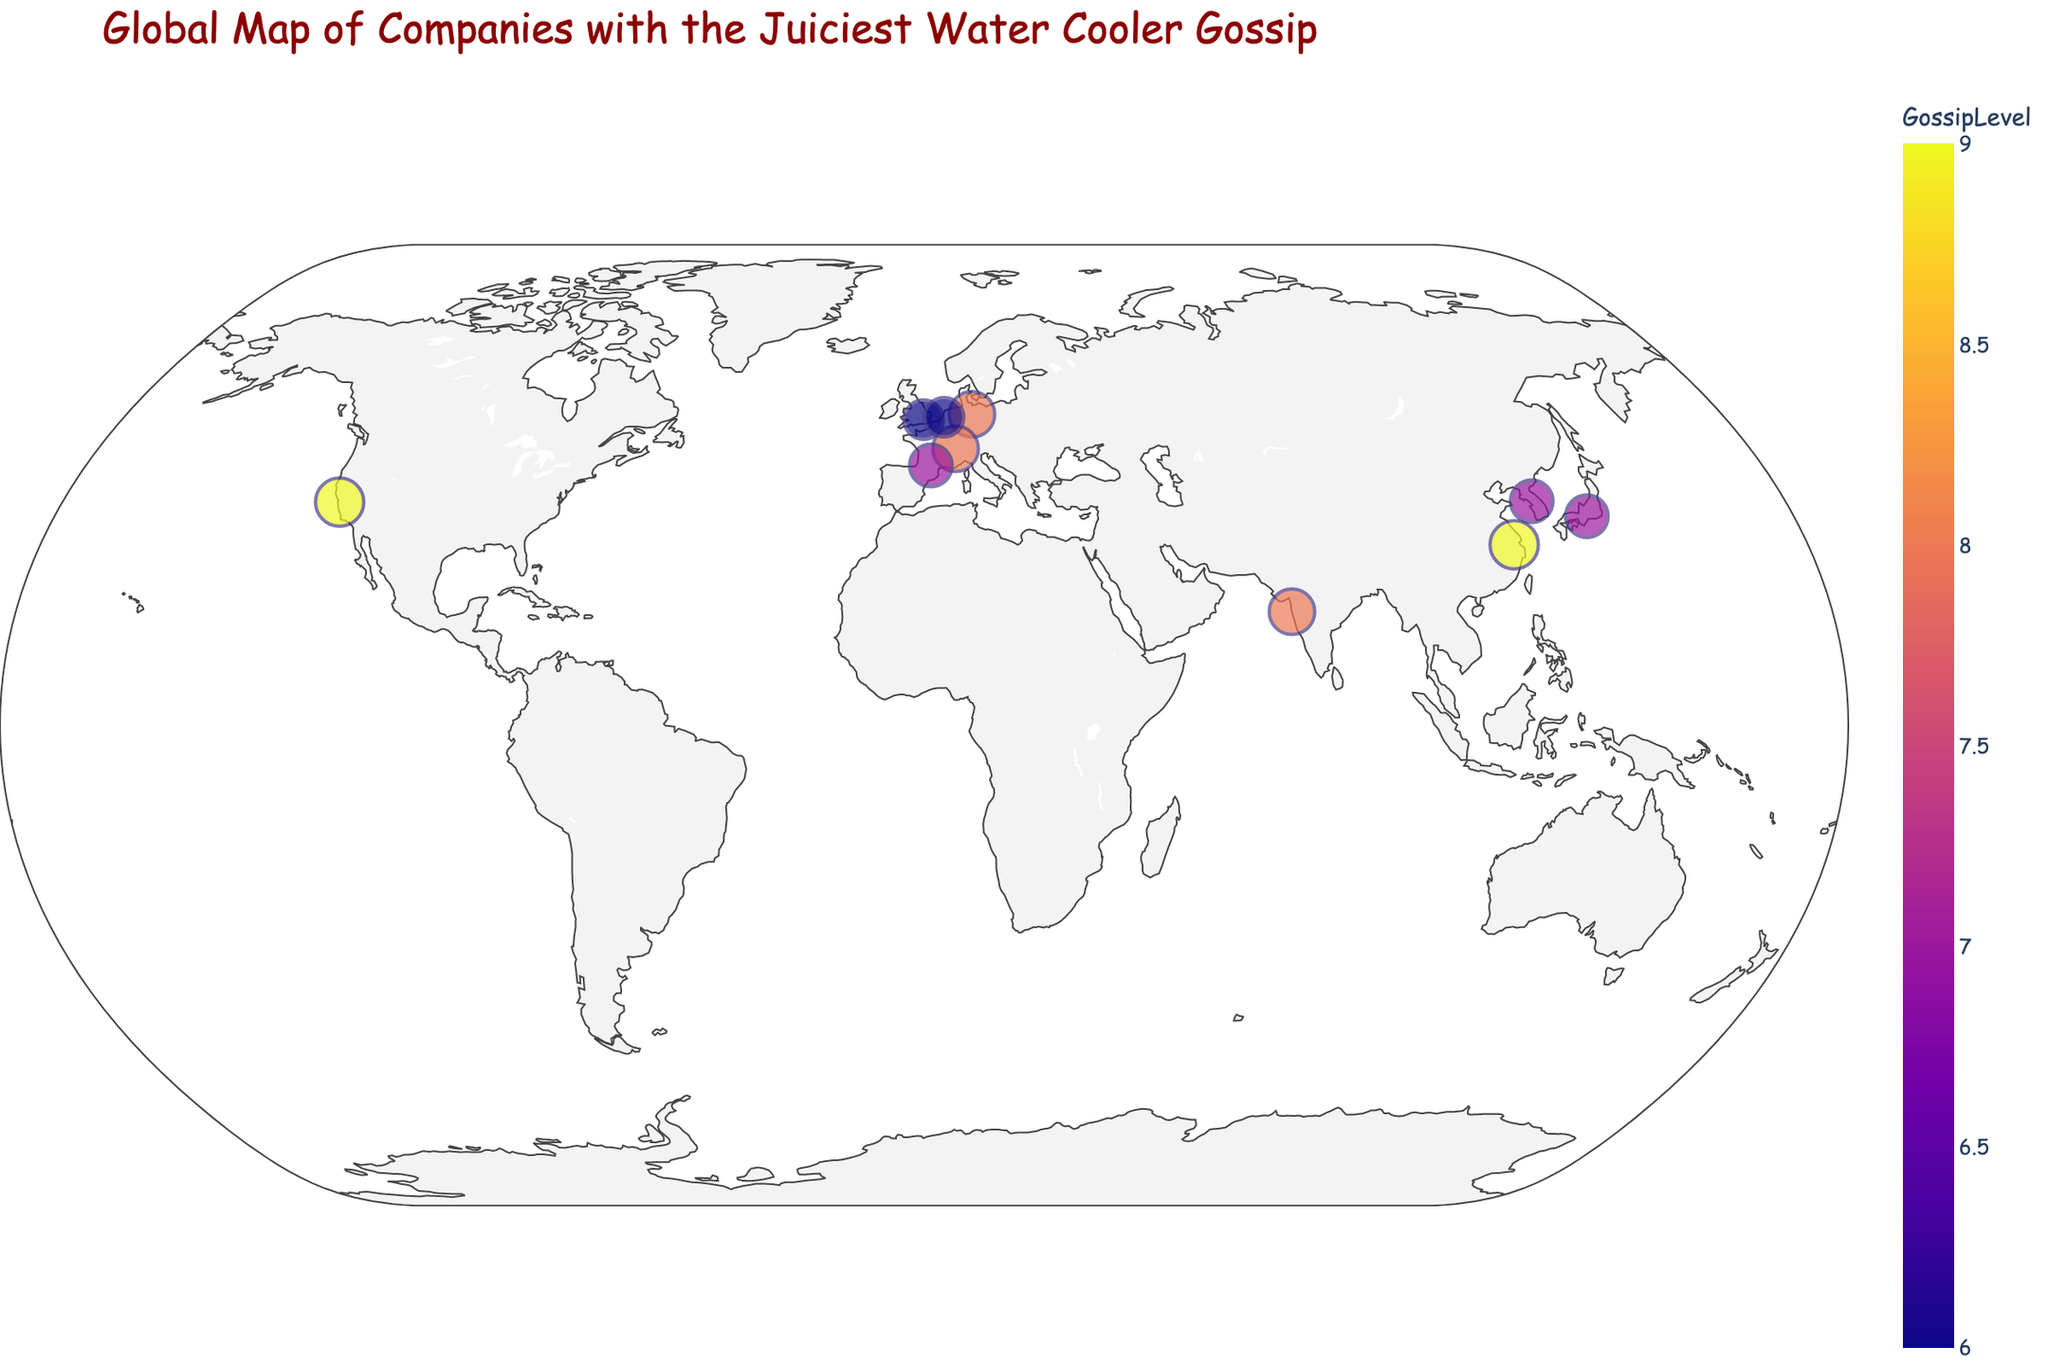What is the title of the plot? The title is usually displayed at the top of the plot. This provides a quick summary of what the plot is about. Here, you'd look at the top of the plot to find the title.
Answer: Global Map of Companies with the Juiciest Water Cooler Gossip How many companies are represented on the map? Count the number of points (markers) on the map. Each marker represents a company.
Answer: 10 Which company has the highest gossip level and what is the hottest rumor associated with it? Look for the marker with the largest size and the most intense color, then check the hover text or annotation.
Answer: Google, CEO's secret underground disco bunker What are the latitudes and longitudes of the companies with the two highest gossip levels? Identify the two companies with the largest markers, which have the highest gossip levels, and note their coordinates.
Answer: Google (37.4220, -122.0841) and Alibaba (30.2741, 120.1551) Which country has the most companies featured on this map? Look at the hover text or annotations for each marker and count the occurrences of each country.
Answer: USA Compare the gossip levels of Samsung and Toyota. Which one is higher and by how much? Identify the markers for Samsung and Toyota, check their gossip levels, and subtract the lower from the higher.
Answer: Samsung, by 0 What is the hottest rumor at Nestle? Find the Nestle marker on the map and look at the hover text to see the hottest rumor.
Answer: Secret ingredient in chocolates: unicorn tears Which company in Europe has the lowest gossip level and what's the level? Identify the European countries, look for the smallest marker, and note the gossip level.
Answer: BP, 6 How many companies in the map have a gossip level greater than or equal to 8? Count the number of markers with gossip levels 8 or above.
Answer: 5 What is the average gossip level of all the companies on the map? Sum all the gossip levels and divide by the number of companies. (9+8+7+9+6+8+7+8+6+7) / 10 = 7.5
Answer: 7.5 